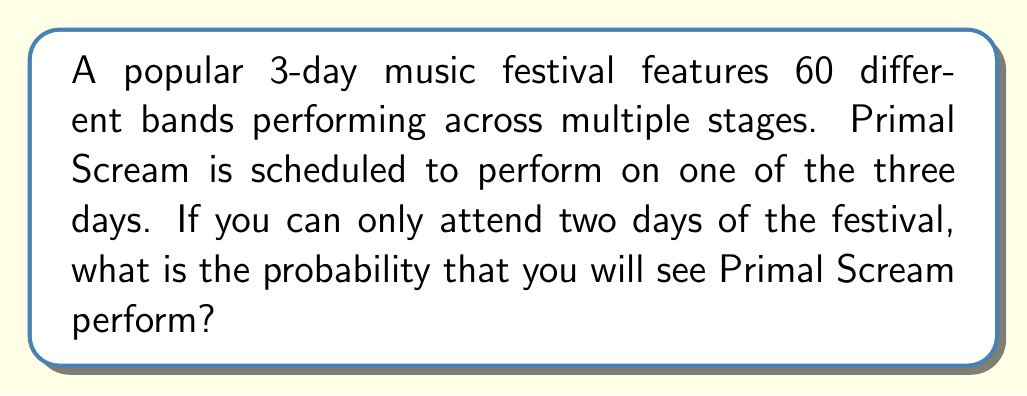Give your solution to this math problem. Let's approach this step-by-step:

1) First, we need to understand what the question is asking. We're looking for the probability of seeing Primal Scream when attending 2 out of 3 days of the festival.

2) We know that Primal Scream is definitely performing on one of the three days.

3) To calculate this probability, we can use the complement method. It's easier to calculate the probability of NOT seeing Primal Scream and then subtract that from 1.

4) The probability of NOT seeing Primal Scream is equal to the probability of choosing the two days when Primal Scream is not performing.

5) There are $\binom{3}{2} = 3$ ways to choose 2 days out of 3.

6) There is only 1 way to choose the 2 days when Primal Scream is not performing.

7) Therefore, the probability of NOT seeing Primal Scream is:

   $$P(\text{not seeing Primal Scream}) = \frac{1}{3}$$

8) The probability of seeing Primal Scream is the complement of this:

   $$P(\text{seeing Primal Scream}) = 1 - P(\text{not seeing Primal Scream}) = 1 - \frac{1}{3} = \frac{2}{3}$$

Thus, the probability of seeing Primal Scream when attending 2 out of 3 days of the festival is $\frac{2}{3}$ or approximately 0.6667.
Answer: $\frac{2}{3}$ or approximately 0.6667 (66.67%) 